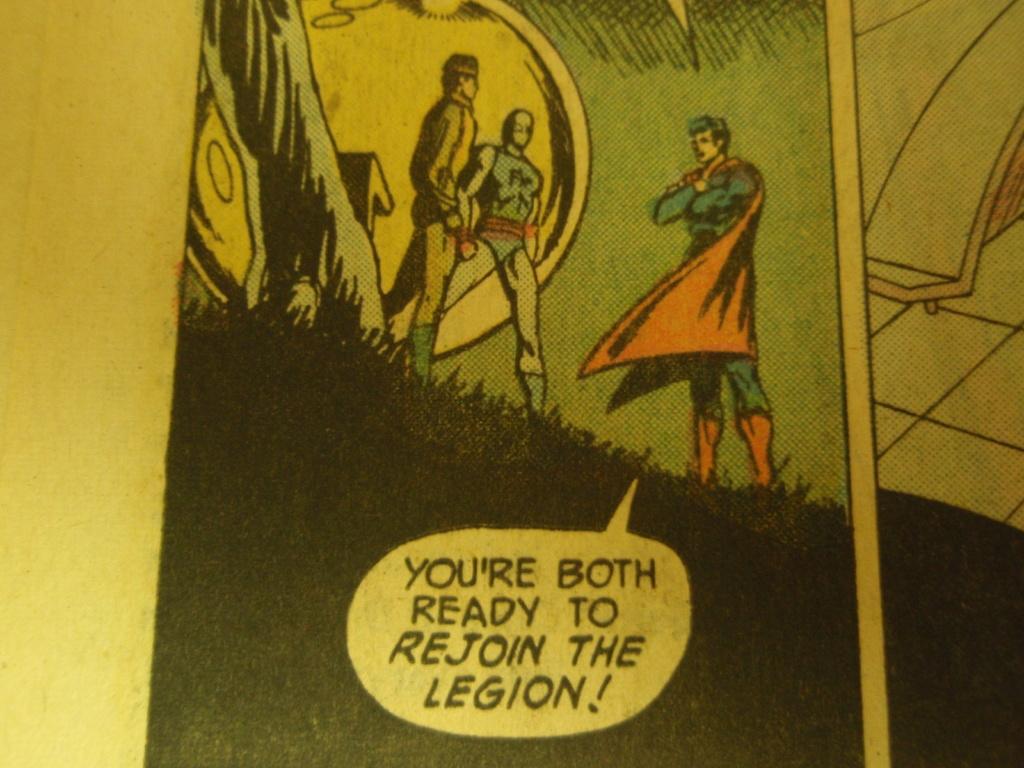What is the first letter of the first word of his dialogue?
Provide a succinct answer. Y. 